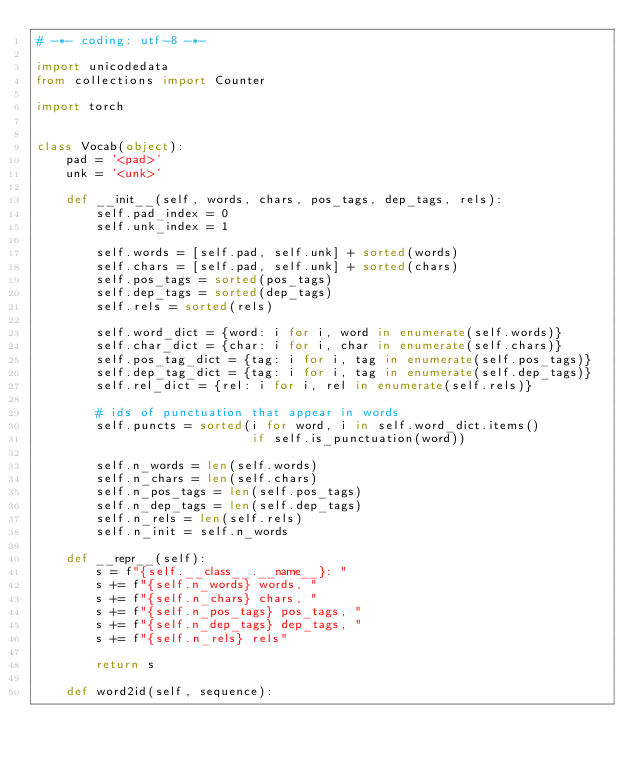<code> <loc_0><loc_0><loc_500><loc_500><_Python_># -*- coding: utf-8 -*-

import unicodedata
from collections import Counter

import torch


class Vocab(object):
    pad = '<pad>'
    unk = '<unk>'

    def __init__(self, words, chars, pos_tags, dep_tags, rels):
        self.pad_index = 0
        self.unk_index = 1

        self.words = [self.pad, self.unk] + sorted(words)
        self.chars = [self.pad, self.unk] + sorted(chars)
        self.pos_tags = sorted(pos_tags)
        self.dep_tags = sorted(dep_tags)
        self.rels = sorted(rels)

        self.word_dict = {word: i for i, word in enumerate(self.words)}
        self.char_dict = {char: i for i, char in enumerate(self.chars)}
        self.pos_tag_dict = {tag: i for i, tag in enumerate(self.pos_tags)}
        self.dep_tag_dict = {tag: i for i, tag in enumerate(self.dep_tags)}
        self.rel_dict = {rel: i for i, rel in enumerate(self.rels)}

        # ids of punctuation that appear in words
        self.puncts = sorted(i for word, i in self.word_dict.items()
                             if self.is_punctuation(word))

        self.n_words = len(self.words)
        self.n_chars = len(self.chars)
        self.n_pos_tags = len(self.pos_tags)
        self.n_dep_tags = len(self.dep_tags)
        self.n_rels = len(self.rels)
        self.n_init = self.n_words

    def __repr__(self):
        s = f"{self.__class__.__name__}: "
        s += f"{self.n_words} words, "
        s += f"{self.n_chars} chars, "
        s += f"{self.n_pos_tags} pos_tags, "
        s += f"{self.n_dep_tags} dep_tags, "
        s += f"{self.n_rels} rels"

        return s

    def word2id(self, sequence):</code> 